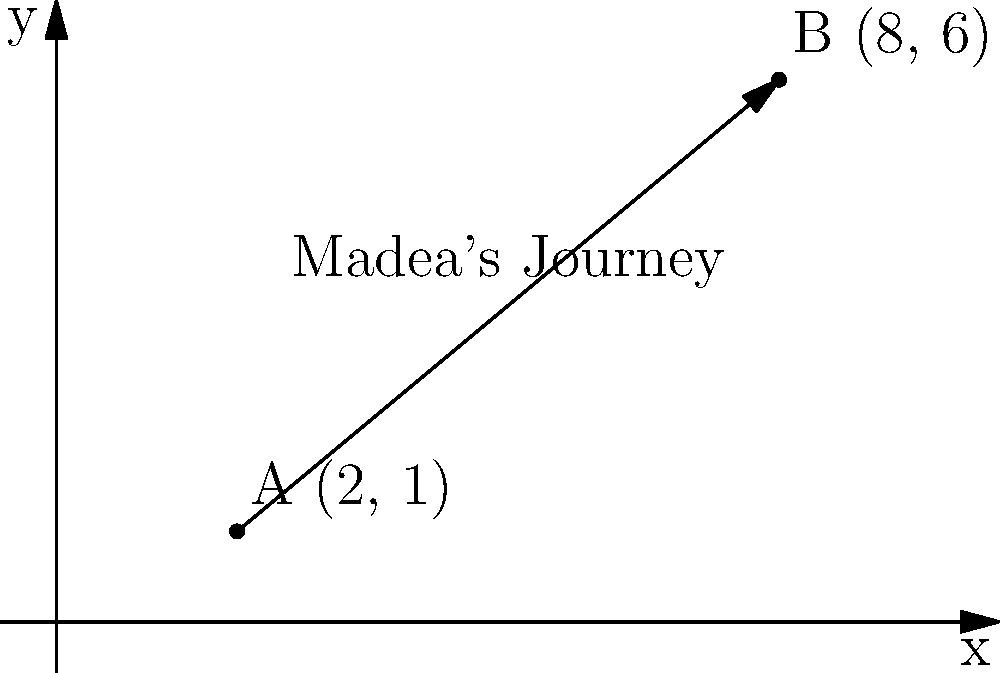In Tyler Perry's "Madea Goes to Jail," Madea embarks on a journey of personal growth and empowerment. On a coordinate plane, her starting point is represented by A(2, 1), and her destination is represented by B(8, 6). Calculate the distance Madea travels on her transformative journey. To find the distance between two points on a coordinate plane, we can use the distance formula:

$$d = \sqrt{(x_2 - x_1)^2 + (y_2 - y_1)^2}$$

Where $(x_1, y_1)$ is the starting point and $(x_2, y_2)$ is the ending point.

Let's plug in our values:
$(x_1, y_1) = (2, 1)$ and $(x_2, y_2) = (8, 6)$

1) First, calculate the differences:
   $x_2 - x_1 = 8 - 2 = 6$
   $y_2 - y_1 = 6 - 1 = 5$

2) Square these differences:
   $(x_2 - x_1)^2 = 6^2 = 36$
   $(y_2 - y_1)^2 = 5^2 = 25$

3) Add the squared differences:
   $36 + 25 = 61$

4) Take the square root of the sum:
   $\sqrt{61}$

Therefore, the distance Madea travels is $\sqrt{61}$ units.
Answer: $\sqrt{61}$ units 